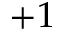<formula> <loc_0><loc_0><loc_500><loc_500>+ 1</formula> 